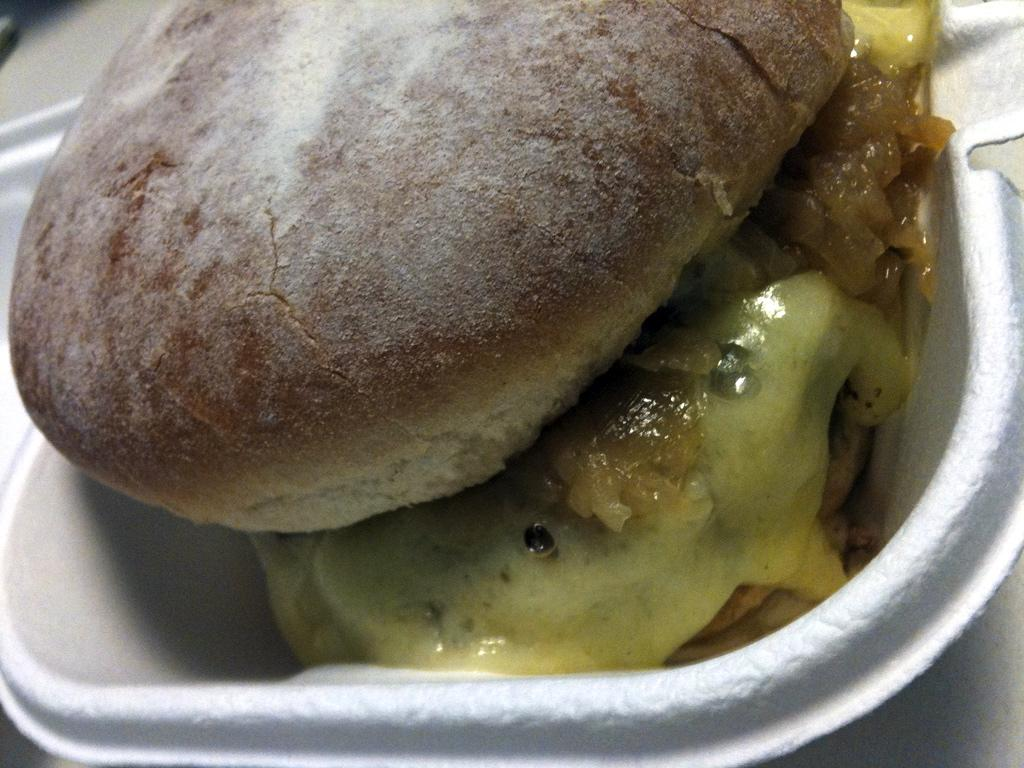What type of objects can be seen in the image? There are food items in the image. How are the food items arranged or contained? The food items are in a white bowl. What color is the hair of the person in the image? There is no person present in the image, so there is no hair to describe. 